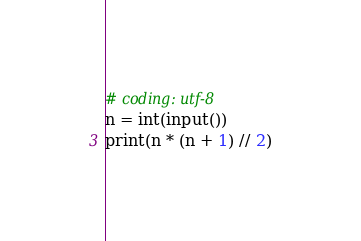Convert code to text. <code><loc_0><loc_0><loc_500><loc_500><_Python_># coding: utf-8
n = int(input())
print(n * (n + 1) // 2)</code> 